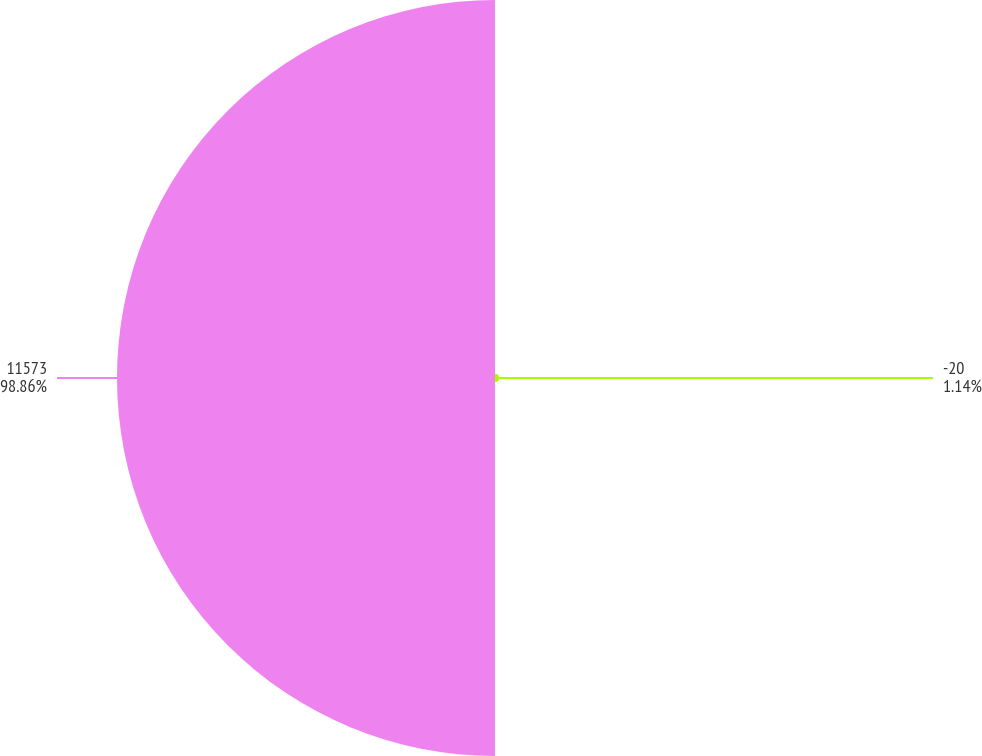<chart> <loc_0><loc_0><loc_500><loc_500><pie_chart><fcel>-20<fcel>11573<nl><fcel>1.14%<fcel>98.86%<nl></chart> 